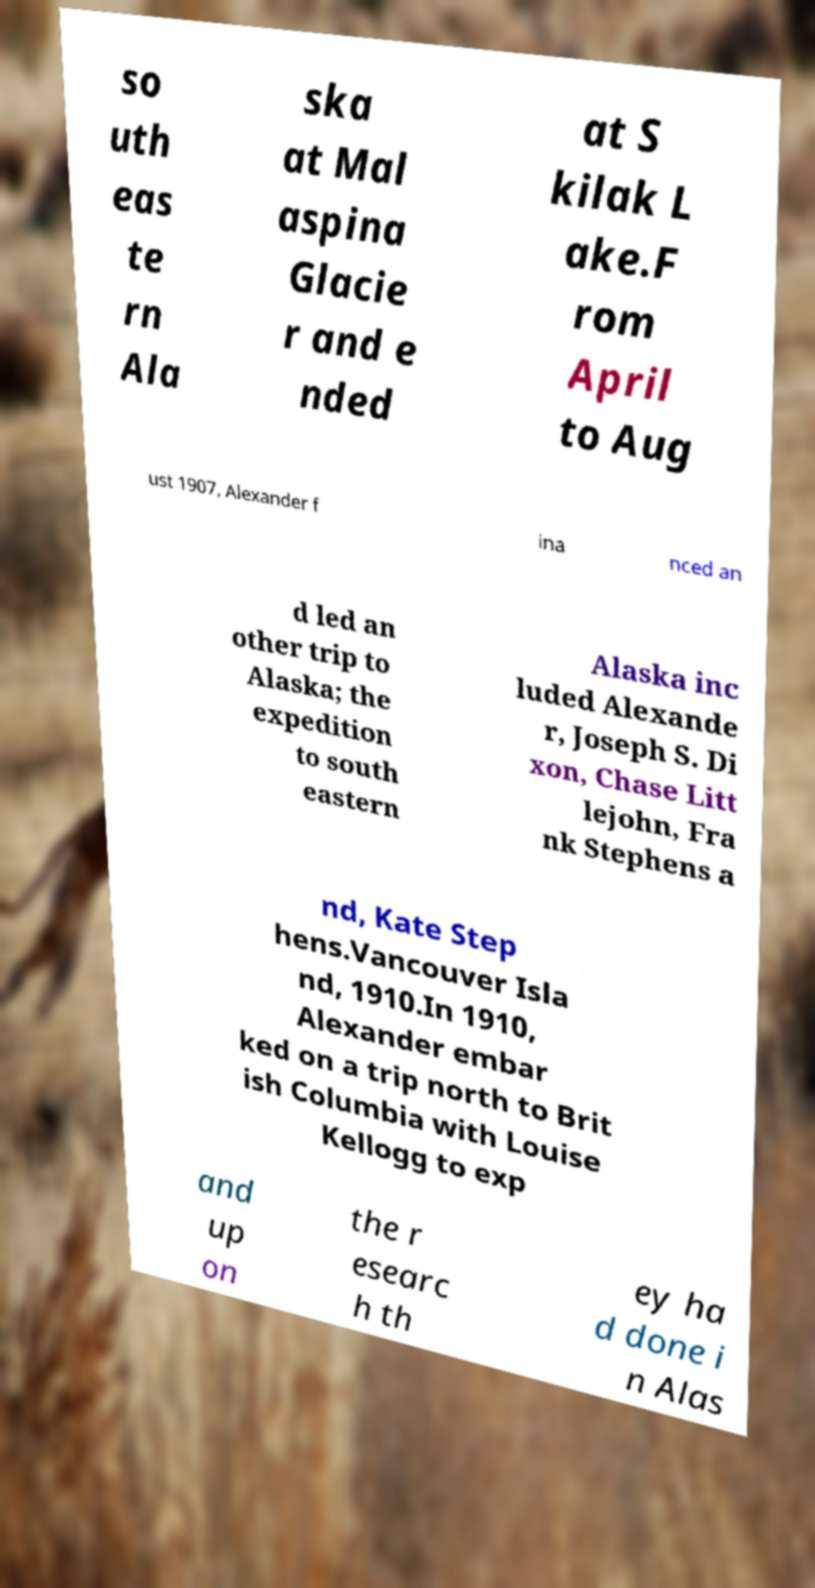Please read and relay the text visible in this image. What does it say? so uth eas te rn Ala ska at Mal aspina Glacie r and e nded at S kilak L ake.F rom April to Aug ust 1907, Alexander f ina nced an d led an other trip to Alaska; the expedition to south eastern Alaska inc luded Alexande r, Joseph S. Di xon, Chase Litt lejohn, Fra nk Stephens a nd, Kate Step hens.Vancouver Isla nd, 1910.In 1910, Alexander embar ked on a trip north to Brit ish Columbia with Louise Kellogg to exp and up on the r esearc h th ey ha d done i n Alas 